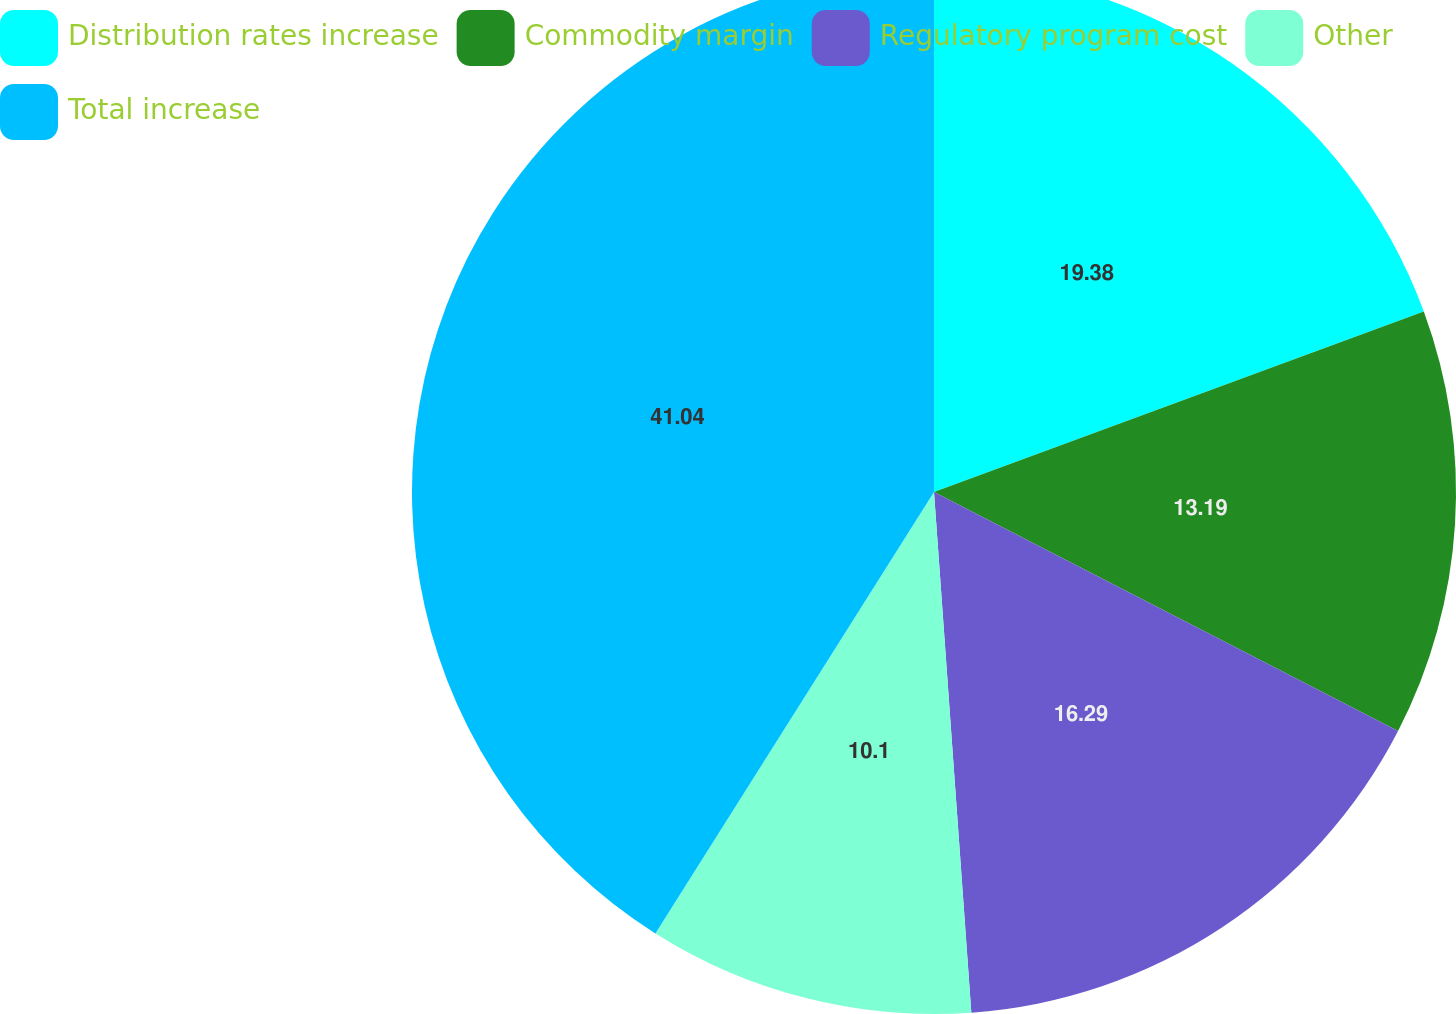<chart> <loc_0><loc_0><loc_500><loc_500><pie_chart><fcel>Distribution rates increase<fcel>Commodity margin<fcel>Regulatory program cost<fcel>Other<fcel>Total increase<nl><fcel>19.38%<fcel>13.19%<fcel>16.29%<fcel>10.1%<fcel>41.04%<nl></chart> 